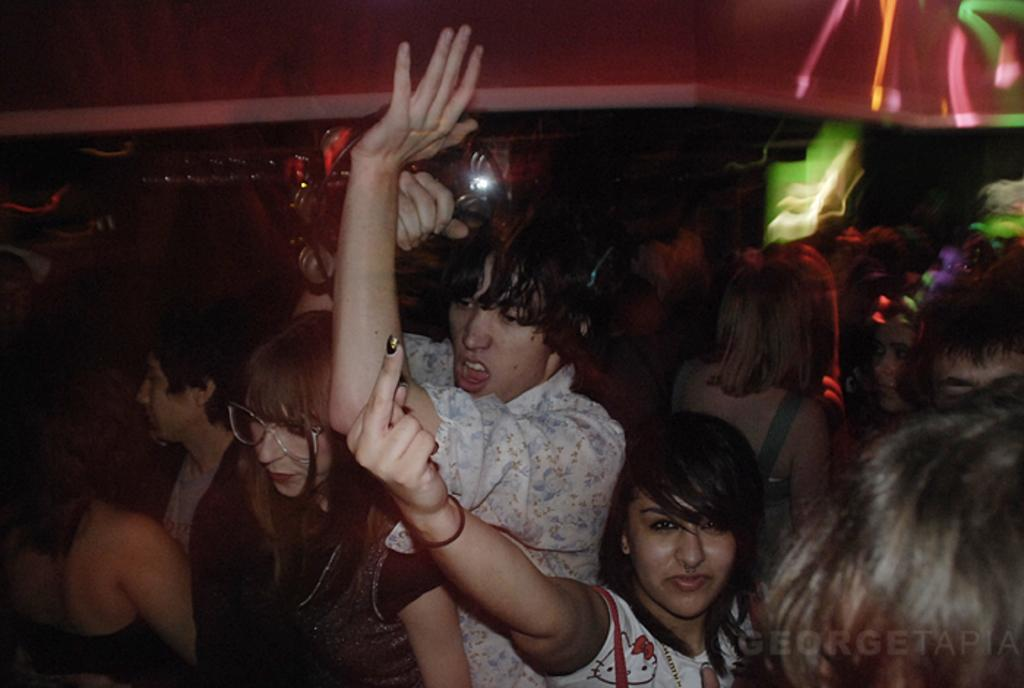What is the main subject of the image? The main subject of the image is people standing. Are there any additional elements in the image besides the people? Yes, there are lights visible in the top right corner of the image, and there is a watermark in the bottom right corner of the image. What type of flooring can be seen in the image? There is no information about the flooring in the image, as the focus is on the people standing and the lights and watermark in the corners. 